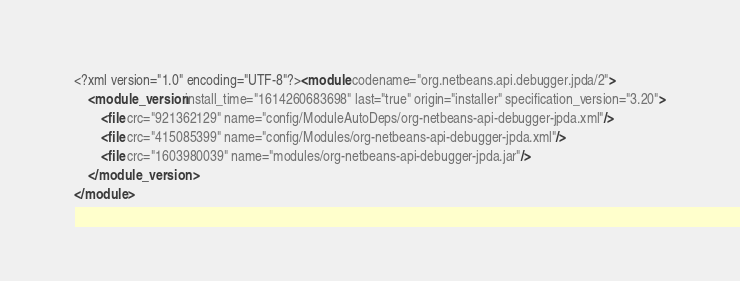Convert code to text. <code><loc_0><loc_0><loc_500><loc_500><_XML_><?xml version="1.0" encoding="UTF-8"?><module codename="org.netbeans.api.debugger.jpda/2">
    <module_version install_time="1614260683698" last="true" origin="installer" specification_version="3.20">
        <file crc="921362129" name="config/ModuleAutoDeps/org-netbeans-api-debugger-jpda.xml"/>
        <file crc="415085399" name="config/Modules/org-netbeans-api-debugger-jpda.xml"/>
        <file crc="1603980039" name="modules/org-netbeans-api-debugger-jpda.jar"/>
    </module_version>
</module>
</code> 